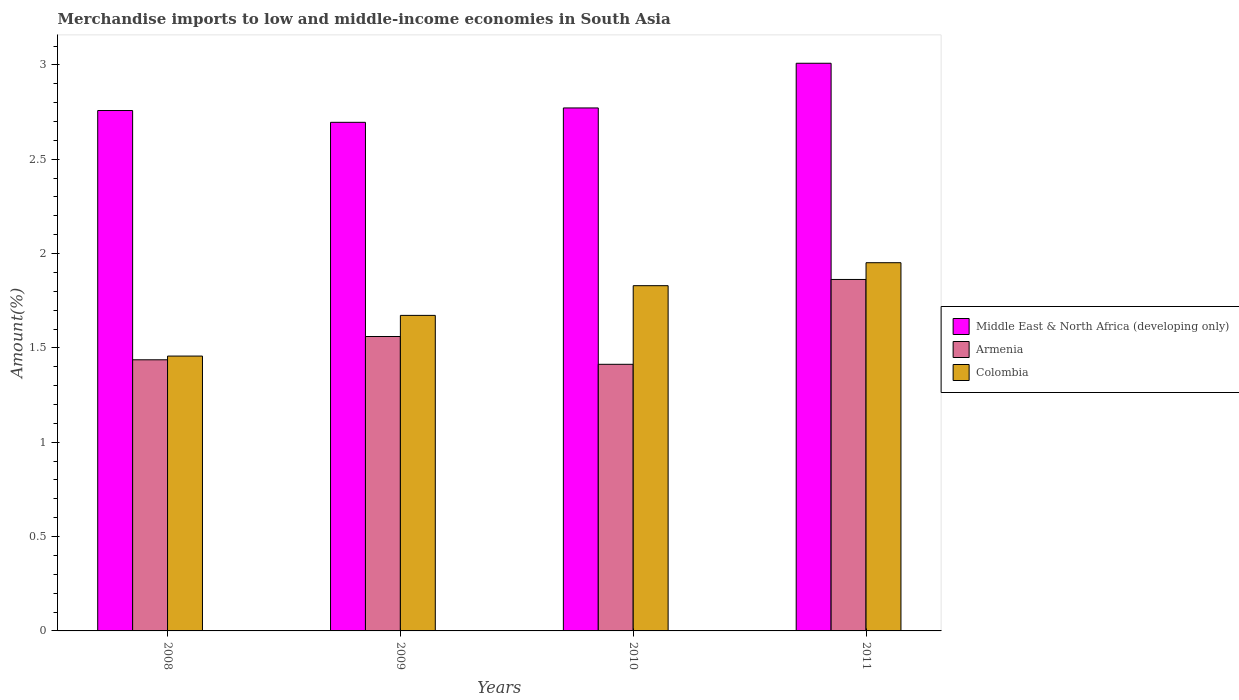How many different coloured bars are there?
Ensure brevity in your answer.  3. How many groups of bars are there?
Offer a very short reply. 4. Are the number of bars per tick equal to the number of legend labels?
Offer a terse response. Yes. What is the label of the 1st group of bars from the left?
Keep it short and to the point. 2008. In how many cases, is the number of bars for a given year not equal to the number of legend labels?
Make the answer very short. 0. What is the percentage of amount earned from merchandise imports in Middle East & North Africa (developing only) in 2010?
Provide a succinct answer. 2.77. Across all years, what is the maximum percentage of amount earned from merchandise imports in Middle East & North Africa (developing only)?
Ensure brevity in your answer.  3.01. Across all years, what is the minimum percentage of amount earned from merchandise imports in Colombia?
Provide a succinct answer. 1.46. In which year was the percentage of amount earned from merchandise imports in Middle East & North Africa (developing only) maximum?
Your answer should be very brief. 2011. What is the total percentage of amount earned from merchandise imports in Middle East & North Africa (developing only) in the graph?
Give a very brief answer. 11.23. What is the difference between the percentage of amount earned from merchandise imports in Middle East & North Africa (developing only) in 2010 and that in 2011?
Make the answer very short. -0.24. What is the difference between the percentage of amount earned from merchandise imports in Armenia in 2011 and the percentage of amount earned from merchandise imports in Middle East & North Africa (developing only) in 2008?
Offer a terse response. -0.9. What is the average percentage of amount earned from merchandise imports in Colombia per year?
Ensure brevity in your answer.  1.73. In the year 2010, what is the difference between the percentage of amount earned from merchandise imports in Colombia and percentage of amount earned from merchandise imports in Armenia?
Provide a short and direct response. 0.42. What is the ratio of the percentage of amount earned from merchandise imports in Middle East & North Africa (developing only) in 2009 to that in 2010?
Provide a short and direct response. 0.97. Is the percentage of amount earned from merchandise imports in Middle East & North Africa (developing only) in 2008 less than that in 2011?
Ensure brevity in your answer.  Yes. What is the difference between the highest and the second highest percentage of amount earned from merchandise imports in Middle East & North Africa (developing only)?
Provide a succinct answer. 0.24. What is the difference between the highest and the lowest percentage of amount earned from merchandise imports in Middle East & North Africa (developing only)?
Make the answer very short. 0.31. In how many years, is the percentage of amount earned from merchandise imports in Colombia greater than the average percentage of amount earned from merchandise imports in Colombia taken over all years?
Make the answer very short. 2. Is the sum of the percentage of amount earned from merchandise imports in Middle East & North Africa (developing only) in 2009 and 2010 greater than the maximum percentage of amount earned from merchandise imports in Armenia across all years?
Make the answer very short. Yes. What does the 2nd bar from the left in 2009 represents?
Your response must be concise. Armenia. What does the 3rd bar from the right in 2009 represents?
Make the answer very short. Middle East & North Africa (developing only). How many years are there in the graph?
Make the answer very short. 4. Are the values on the major ticks of Y-axis written in scientific E-notation?
Ensure brevity in your answer.  No. Does the graph contain grids?
Make the answer very short. No. What is the title of the graph?
Your answer should be compact. Merchandise imports to low and middle-income economies in South Asia. What is the label or title of the X-axis?
Give a very brief answer. Years. What is the label or title of the Y-axis?
Keep it short and to the point. Amount(%). What is the Amount(%) in Middle East & North Africa (developing only) in 2008?
Offer a very short reply. 2.76. What is the Amount(%) in Armenia in 2008?
Offer a very short reply. 1.44. What is the Amount(%) of Colombia in 2008?
Your response must be concise. 1.46. What is the Amount(%) of Middle East & North Africa (developing only) in 2009?
Provide a succinct answer. 2.7. What is the Amount(%) of Armenia in 2009?
Provide a succinct answer. 1.56. What is the Amount(%) in Colombia in 2009?
Offer a terse response. 1.67. What is the Amount(%) in Middle East & North Africa (developing only) in 2010?
Offer a very short reply. 2.77. What is the Amount(%) in Armenia in 2010?
Provide a short and direct response. 1.41. What is the Amount(%) in Colombia in 2010?
Keep it short and to the point. 1.83. What is the Amount(%) in Middle East & North Africa (developing only) in 2011?
Give a very brief answer. 3.01. What is the Amount(%) of Armenia in 2011?
Give a very brief answer. 1.86. What is the Amount(%) of Colombia in 2011?
Offer a terse response. 1.95. Across all years, what is the maximum Amount(%) in Middle East & North Africa (developing only)?
Provide a short and direct response. 3.01. Across all years, what is the maximum Amount(%) in Armenia?
Keep it short and to the point. 1.86. Across all years, what is the maximum Amount(%) in Colombia?
Provide a short and direct response. 1.95. Across all years, what is the minimum Amount(%) of Middle East & North Africa (developing only)?
Your response must be concise. 2.7. Across all years, what is the minimum Amount(%) of Armenia?
Your answer should be compact. 1.41. Across all years, what is the minimum Amount(%) of Colombia?
Ensure brevity in your answer.  1.46. What is the total Amount(%) in Middle East & North Africa (developing only) in the graph?
Make the answer very short. 11.23. What is the total Amount(%) of Armenia in the graph?
Offer a very short reply. 6.27. What is the total Amount(%) in Colombia in the graph?
Make the answer very short. 6.91. What is the difference between the Amount(%) of Middle East & North Africa (developing only) in 2008 and that in 2009?
Keep it short and to the point. 0.06. What is the difference between the Amount(%) in Armenia in 2008 and that in 2009?
Offer a terse response. -0.12. What is the difference between the Amount(%) in Colombia in 2008 and that in 2009?
Make the answer very short. -0.22. What is the difference between the Amount(%) of Middle East & North Africa (developing only) in 2008 and that in 2010?
Ensure brevity in your answer.  -0.01. What is the difference between the Amount(%) in Armenia in 2008 and that in 2010?
Offer a very short reply. 0.02. What is the difference between the Amount(%) in Colombia in 2008 and that in 2010?
Your answer should be very brief. -0.37. What is the difference between the Amount(%) in Middle East & North Africa (developing only) in 2008 and that in 2011?
Make the answer very short. -0.25. What is the difference between the Amount(%) in Armenia in 2008 and that in 2011?
Give a very brief answer. -0.43. What is the difference between the Amount(%) of Colombia in 2008 and that in 2011?
Your answer should be compact. -0.49. What is the difference between the Amount(%) of Middle East & North Africa (developing only) in 2009 and that in 2010?
Your answer should be very brief. -0.08. What is the difference between the Amount(%) in Armenia in 2009 and that in 2010?
Make the answer very short. 0.15. What is the difference between the Amount(%) in Colombia in 2009 and that in 2010?
Offer a terse response. -0.16. What is the difference between the Amount(%) of Middle East & North Africa (developing only) in 2009 and that in 2011?
Keep it short and to the point. -0.31. What is the difference between the Amount(%) in Armenia in 2009 and that in 2011?
Your answer should be very brief. -0.3. What is the difference between the Amount(%) in Colombia in 2009 and that in 2011?
Your response must be concise. -0.28. What is the difference between the Amount(%) of Middle East & North Africa (developing only) in 2010 and that in 2011?
Provide a succinct answer. -0.24. What is the difference between the Amount(%) in Armenia in 2010 and that in 2011?
Offer a terse response. -0.45. What is the difference between the Amount(%) in Colombia in 2010 and that in 2011?
Ensure brevity in your answer.  -0.12. What is the difference between the Amount(%) of Middle East & North Africa (developing only) in 2008 and the Amount(%) of Armenia in 2009?
Give a very brief answer. 1.2. What is the difference between the Amount(%) of Middle East & North Africa (developing only) in 2008 and the Amount(%) of Colombia in 2009?
Your answer should be compact. 1.09. What is the difference between the Amount(%) of Armenia in 2008 and the Amount(%) of Colombia in 2009?
Your answer should be very brief. -0.24. What is the difference between the Amount(%) in Middle East & North Africa (developing only) in 2008 and the Amount(%) in Armenia in 2010?
Make the answer very short. 1.35. What is the difference between the Amount(%) in Middle East & North Africa (developing only) in 2008 and the Amount(%) in Colombia in 2010?
Ensure brevity in your answer.  0.93. What is the difference between the Amount(%) in Armenia in 2008 and the Amount(%) in Colombia in 2010?
Your answer should be very brief. -0.39. What is the difference between the Amount(%) in Middle East & North Africa (developing only) in 2008 and the Amount(%) in Armenia in 2011?
Ensure brevity in your answer.  0.9. What is the difference between the Amount(%) of Middle East & North Africa (developing only) in 2008 and the Amount(%) of Colombia in 2011?
Offer a terse response. 0.81. What is the difference between the Amount(%) in Armenia in 2008 and the Amount(%) in Colombia in 2011?
Your response must be concise. -0.51. What is the difference between the Amount(%) in Middle East & North Africa (developing only) in 2009 and the Amount(%) in Armenia in 2010?
Provide a short and direct response. 1.28. What is the difference between the Amount(%) in Middle East & North Africa (developing only) in 2009 and the Amount(%) in Colombia in 2010?
Your answer should be very brief. 0.87. What is the difference between the Amount(%) of Armenia in 2009 and the Amount(%) of Colombia in 2010?
Provide a succinct answer. -0.27. What is the difference between the Amount(%) of Middle East & North Africa (developing only) in 2009 and the Amount(%) of Armenia in 2011?
Provide a succinct answer. 0.83. What is the difference between the Amount(%) in Middle East & North Africa (developing only) in 2009 and the Amount(%) in Colombia in 2011?
Your response must be concise. 0.74. What is the difference between the Amount(%) of Armenia in 2009 and the Amount(%) of Colombia in 2011?
Offer a very short reply. -0.39. What is the difference between the Amount(%) of Middle East & North Africa (developing only) in 2010 and the Amount(%) of Armenia in 2011?
Provide a succinct answer. 0.91. What is the difference between the Amount(%) in Middle East & North Africa (developing only) in 2010 and the Amount(%) in Colombia in 2011?
Offer a very short reply. 0.82. What is the difference between the Amount(%) in Armenia in 2010 and the Amount(%) in Colombia in 2011?
Your answer should be compact. -0.54. What is the average Amount(%) in Middle East & North Africa (developing only) per year?
Provide a short and direct response. 2.81. What is the average Amount(%) of Armenia per year?
Your answer should be very brief. 1.57. What is the average Amount(%) in Colombia per year?
Make the answer very short. 1.73. In the year 2008, what is the difference between the Amount(%) of Middle East & North Africa (developing only) and Amount(%) of Armenia?
Your answer should be very brief. 1.32. In the year 2008, what is the difference between the Amount(%) in Middle East & North Africa (developing only) and Amount(%) in Colombia?
Provide a succinct answer. 1.3. In the year 2008, what is the difference between the Amount(%) in Armenia and Amount(%) in Colombia?
Provide a short and direct response. -0.02. In the year 2009, what is the difference between the Amount(%) in Middle East & North Africa (developing only) and Amount(%) in Armenia?
Your answer should be compact. 1.14. In the year 2009, what is the difference between the Amount(%) in Middle East & North Africa (developing only) and Amount(%) in Colombia?
Offer a very short reply. 1.02. In the year 2009, what is the difference between the Amount(%) in Armenia and Amount(%) in Colombia?
Ensure brevity in your answer.  -0.11. In the year 2010, what is the difference between the Amount(%) in Middle East & North Africa (developing only) and Amount(%) in Armenia?
Ensure brevity in your answer.  1.36. In the year 2010, what is the difference between the Amount(%) in Middle East & North Africa (developing only) and Amount(%) in Colombia?
Provide a short and direct response. 0.94. In the year 2010, what is the difference between the Amount(%) in Armenia and Amount(%) in Colombia?
Keep it short and to the point. -0.42. In the year 2011, what is the difference between the Amount(%) in Middle East & North Africa (developing only) and Amount(%) in Armenia?
Keep it short and to the point. 1.15. In the year 2011, what is the difference between the Amount(%) in Middle East & North Africa (developing only) and Amount(%) in Colombia?
Give a very brief answer. 1.06. In the year 2011, what is the difference between the Amount(%) in Armenia and Amount(%) in Colombia?
Offer a very short reply. -0.09. What is the ratio of the Amount(%) in Middle East & North Africa (developing only) in 2008 to that in 2009?
Make the answer very short. 1.02. What is the ratio of the Amount(%) in Armenia in 2008 to that in 2009?
Provide a short and direct response. 0.92. What is the ratio of the Amount(%) of Colombia in 2008 to that in 2009?
Make the answer very short. 0.87. What is the ratio of the Amount(%) of Armenia in 2008 to that in 2010?
Your response must be concise. 1.02. What is the ratio of the Amount(%) of Colombia in 2008 to that in 2010?
Provide a short and direct response. 0.8. What is the ratio of the Amount(%) of Middle East & North Africa (developing only) in 2008 to that in 2011?
Provide a succinct answer. 0.92. What is the ratio of the Amount(%) of Armenia in 2008 to that in 2011?
Your response must be concise. 0.77. What is the ratio of the Amount(%) of Colombia in 2008 to that in 2011?
Offer a very short reply. 0.75. What is the ratio of the Amount(%) of Middle East & North Africa (developing only) in 2009 to that in 2010?
Your response must be concise. 0.97. What is the ratio of the Amount(%) in Armenia in 2009 to that in 2010?
Make the answer very short. 1.1. What is the ratio of the Amount(%) of Colombia in 2009 to that in 2010?
Offer a very short reply. 0.91. What is the ratio of the Amount(%) of Middle East & North Africa (developing only) in 2009 to that in 2011?
Provide a succinct answer. 0.9. What is the ratio of the Amount(%) in Armenia in 2009 to that in 2011?
Your answer should be very brief. 0.84. What is the ratio of the Amount(%) in Colombia in 2009 to that in 2011?
Your response must be concise. 0.86. What is the ratio of the Amount(%) in Middle East & North Africa (developing only) in 2010 to that in 2011?
Make the answer very short. 0.92. What is the ratio of the Amount(%) in Armenia in 2010 to that in 2011?
Make the answer very short. 0.76. What is the ratio of the Amount(%) in Colombia in 2010 to that in 2011?
Make the answer very short. 0.94. What is the difference between the highest and the second highest Amount(%) of Middle East & North Africa (developing only)?
Make the answer very short. 0.24. What is the difference between the highest and the second highest Amount(%) of Armenia?
Your answer should be very brief. 0.3. What is the difference between the highest and the second highest Amount(%) of Colombia?
Provide a succinct answer. 0.12. What is the difference between the highest and the lowest Amount(%) of Middle East & North Africa (developing only)?
Offer a terse response. 0.31. What is the difference between the highest and the lowest Amount(%) in Armenia?
Your answer should be compact. 0.45. What is the difference between the highest and the lowest Amount(%) in Colombia?
Your answer should be compact. 0.49. 